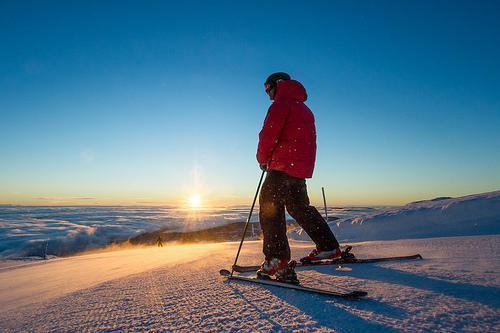How many people are on the hill?
Give a very brief answer. 2. 